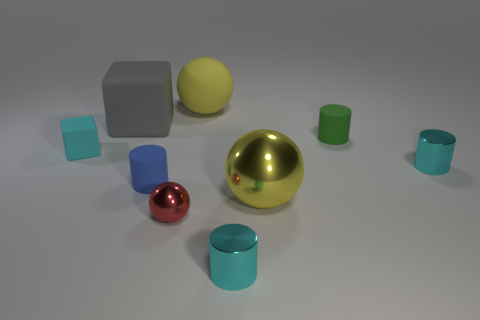There is a yellow object that is in front of the small object behind the cyan thing on the left side of the small blue rubber cylinder; what shape is it? sphere 